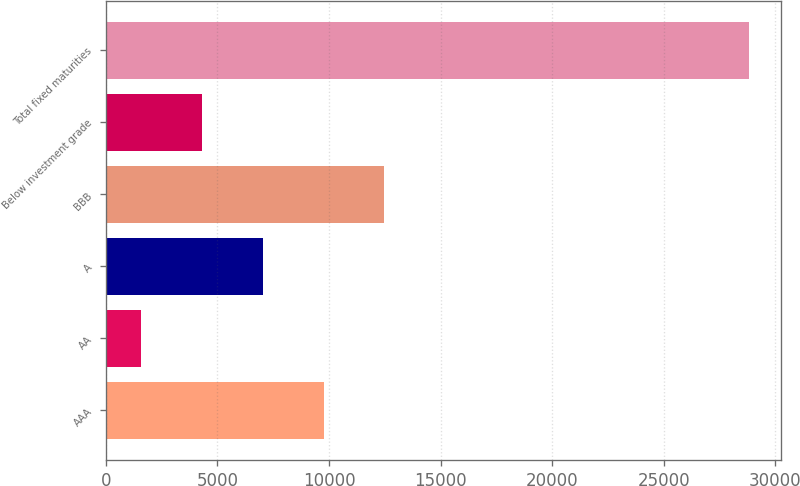<chart> <loc_0><loc_0><loc_500><loc_500><bar_chart><fcel>AAA<fcel>AA<fcel>A<fcel>BBB<fcel>Below investment grade<fcel>Total fixed maturities<nl><fcel>9760.5<fcel>1587<fcel>7036<fcel>12485<fcel>4311.5<fcel>28832<nl></chart> 